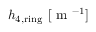<formula> <loc_0><loc_0><loc_500><loc_500>h _ { 4 , r i n g } \ [ m ^ { - 1 } ]</formula> 